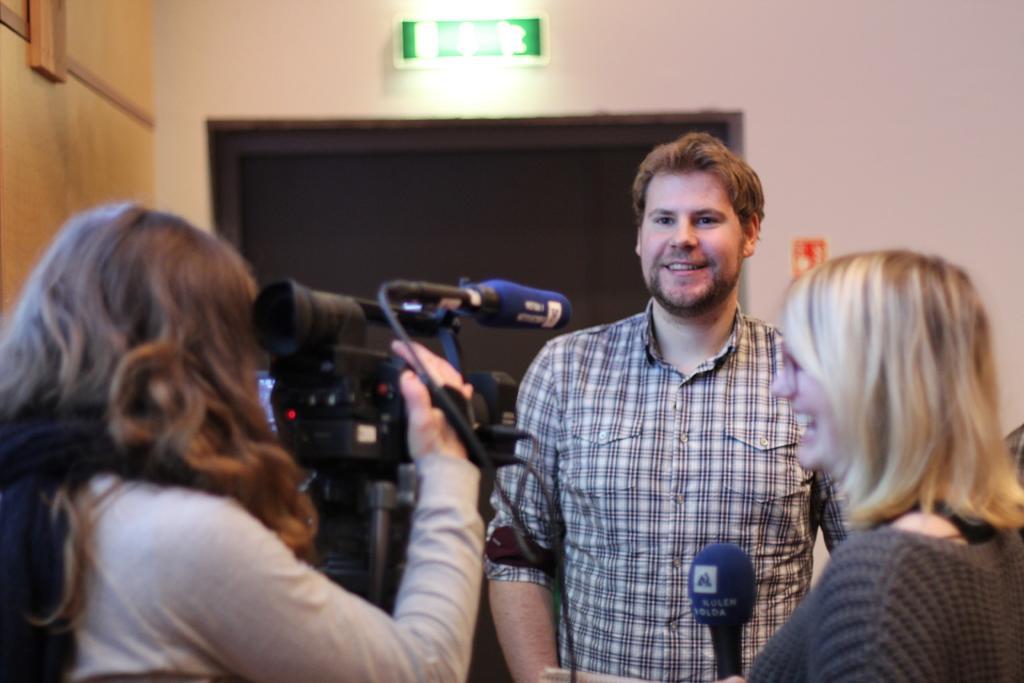Please provide a concise description of this image. on the left side of the image there is a lady holding a camera in her hands. On the right side there is another lady who is holding a mic is smiling. In the center of the image there is a man. In the background there is a door. 